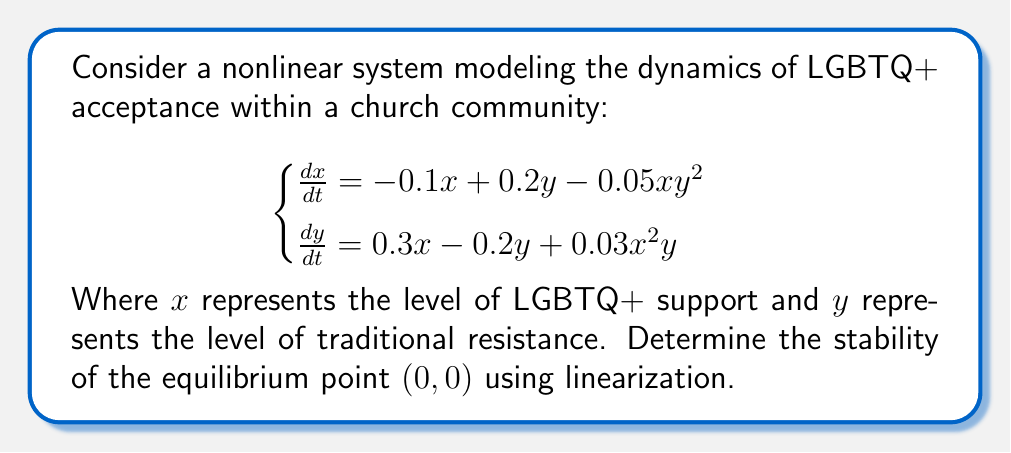Show me your answer to this math problem. To analyze the stability of the equilibrium point $(0,0)$, we need to follow these steps:

1) First, we calculate the Jacobian matrix at the equilibrium point $(0,0)$:

   $$J(x,y) = \begin{bmatrix}
   \frac{\partial f_1}{\partial x} & \frac{\partial f_1}{\partial y} \\
   \frac{\partial f_2}{\partial x} & \frac{\partial f_2}{\partial y}
   \end{bmatrix}$$

   Where $f_1 = -0.1x + 0.2y - 0.05xy^2$ and $f_2 = 0.3x - 0.2y + 0.03x^2y$

2) Calculate the partial derivatives:
   
   $$\frac{\partial f_1}{\partial x} = -0.1 - 0.05y^2$$
   $$\frac{\partial f_1}{\partial y} = 0.2 - 0.1xy$$
   $$\frac{\partial f_2}{\partial x} = 0.3 + 0.06xy$$
   $$\frac{\partial f_2}{\partial y} = -0.2 + 0.03x^2$$

3) Evaluate the Jacobian at $(0,0)$:

   $$J(0,0) = \begin{bmatrix}
   -0.1 & 0.2 \\
   0.3 & -0.2
   \end{bmatrix}$$

4) Calculate the eigenvalues of $J(0,0)$:

   $$\det(J(0,0) - \lambda I) = \begin{vmatrix}
   -0.1 - \lambda & 0.2 \\
   0.3 & -0.2 - \lambda
   \end{vmatrix} = 0$$

   $$(0.1 + \lambda)(0.2 + \lambda) - 0.06 = 0$$
   $$\lambda^2 + 0.3\lambda - 0.04 = 0$$

5) Solve the quadratic equation:

   $$\lambda = \frac{-0.3 \pm \sqrt{0.09 + 0.16}}{2} = \frac{-0.3 \pm \sqrt{0.25}}{2} = \frac{-0.3 \pm 0.5}{2}$$

   $$\lambda_1 = \frac{-0.3 + 0.5}{2} = 0.1$$
   $$\lambda_2 = \frac{-0.3 - 0.5}{2} = -0.4$$

6) Analyze the eigenvalues:
   Since $\lambda_1 > 0$ and $\lambda_2 < 0$, the equilibrium point $(0,0)$ is a saddle point.
Answer: Saddle point (unstable) 